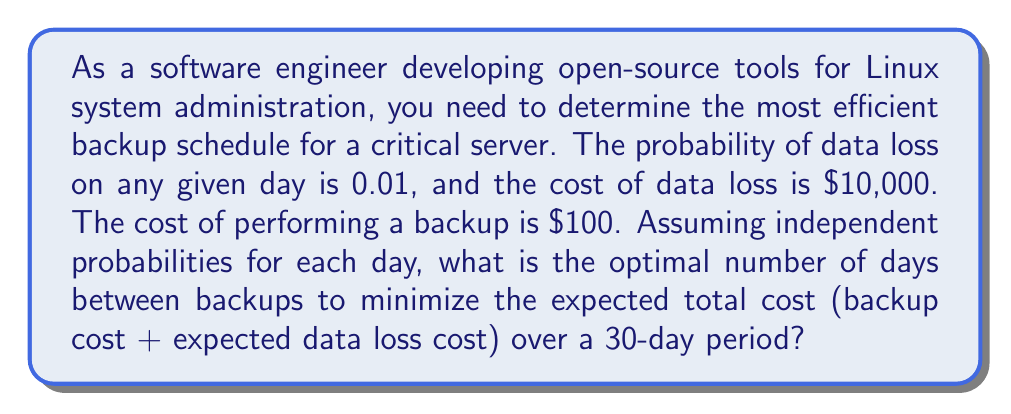Could you help me with this problem? Let's approach this step-by-step:

1) Let $n$ be the number of days between backups.

2) The probability of no data loss in $n$ days is:
   $$(1 - 0.01)^n = 0.99^n$$

3) The probability of data loss in $n$ days is:
   $$1 - 0.99^n$$

4) The expected cost of data loss in $n$ days is:
   $$10000 \cdot (1 - 0.99^n)$$

5) The number of backups in 30 days is $\frac{30}{n}$.

6) The total backup cost in 30 days is:
   $$100 \cdot \frac{30}{n}$$

7) The expected total cost over 30 days is:
   $$E(n) = 100 \cdot \frac{30}{n} + 10000 \cdot (1 - 0.99^n)$$

8) To find the minimum, we differentiate $E(n)$ with respect to $n$ and set it to zero:
   $$\frac{dE}{dn} = -100 \cdot \frac{30}{n^2} - 10000 \cdot 0.99^n \cdot \ln(0.99) = 0$$

9) This equation cannot be solved analytically. We need to use numerical methods or software to find the solution.

10) Using a numerical solver, we find that the optimal value of $n$ is approximately 7.07 days.

11) Since we need to use a whole number of days, we should compare the expected costs for 7 and 8 days:

    For 7 days: $E(7) = 100 \cdot \frac{30}{7} + 10000 \cdot (1 - 0.99^7) \approx 498.93$
    For 8 days: $E(8) = 100 \cdot \frac{30}{8} + 10000 \cdot (1 - 0.99^8) \approx 499.31$

12) Therefore, the optimal backup schedule is every 7 days.
Answer: 7 days 